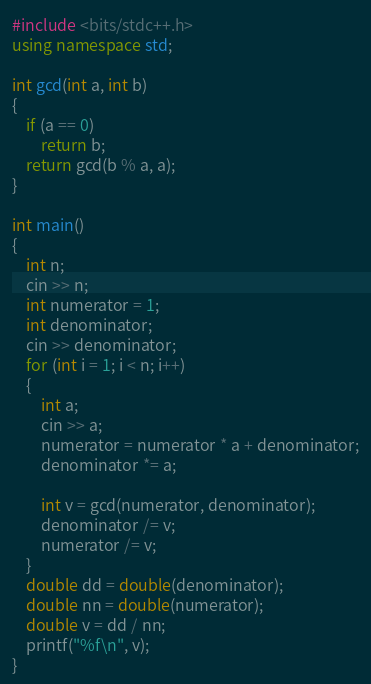<code> <loc_0><loc_0><loc_500><loc_500><_C++_>#include <bits/stdc++.h>
using namespace std;

int gcd(int a, int b)
{
    if (a == 0)
        return b;
    return gcd(b % a, a);
}

int main()
{
    int n;
    cin >> n;
    int numerator = 1;
    int denominator;
    cin >> denominator;
    for (int i = 1; i < n; i++)
    {
        int a;
        cin >> a;
        numerator = numerator * a + denominator;
        denominator *= a;

        int v = gcd(numerator, denominator);
        denominator /= v;
        numerator /= v;
    }
    double dd = double(denominator);
    double nn = double(numerator);
    double v = dd / nn;
    printf("%f\n", v);
}</code> 